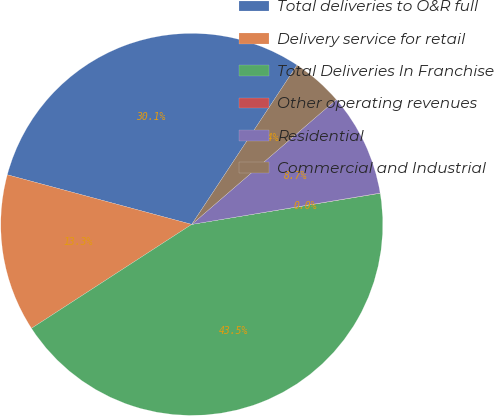Convert chart. <chart><loc_0><loc_0><loc_500><loc_500><pie_chart><fcel>Total deliveries to O&R full<fcel>Delivery service for retail<fcel>Total Deliveries In Franchise<fcel>Other operating revenues<fcel>Residential<fcel>Commercial and Industrial<nl><fcel>30.11%<fcel>13.34%<fcel>43.45%<fcel>0.02%<fcel>8.71%<fcel>4.37%<nl></chart> 